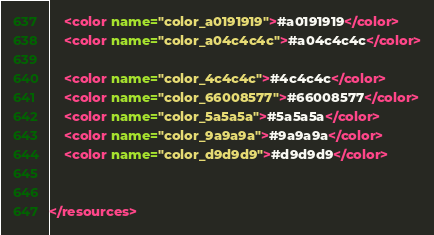Convert code to text. <code><loc_0><loc_0><loc_500><loc_500><_XML_>    <color name="color_a0191919">#a0191919</color>
    <color name="color_a04c4c4c">#a04c4c4c</color>

    <color name="color_4c4c4c">#4c4c4c</color>
    <color name="color_66008577">#66008577</color>
    <color name="color_5a5a5a">#5a5a5a</color>
    <color name="color_9a9a9a">#9a9a9a</color>
    <color name="color_d9d9d9">#d9d9d9</color>


</resources>
</code> 